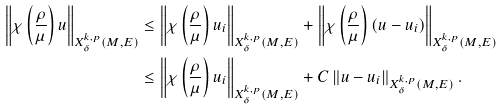Convert formula to latex. <formula><loc_0><loc_0><loc_500><loc_500>\left \| \chi \left ( \frac { \rho } { \mu } \right ) u \right \| _ { X ^ { k , p } _ { \delta } ( M , E ) } & \leq \left \| \chi \left ( \frac { \rho } { \mu } \right ) u _ { i } \right \| _ { X ^ { k , p } _ { \delta } ( M , E ) } + \left \| \chi \left ( \frac { \rho } { \mu } \right ) ( u - u _ { i } ) \right \| _ { X ^ { k , p } _ { \delta } ( M , E ) } \\ & \leq \left \| \chi \left ( \frac { \rho } { \mu } \right ) u _ { i } \right \| _ { X ^ { k , p } _ { \delta } ( M , E ) } + C \left \| u - u _ { i } \right \| _ { X ^ { k , p } _ { \delta } ( M , E ) } .</formula> 